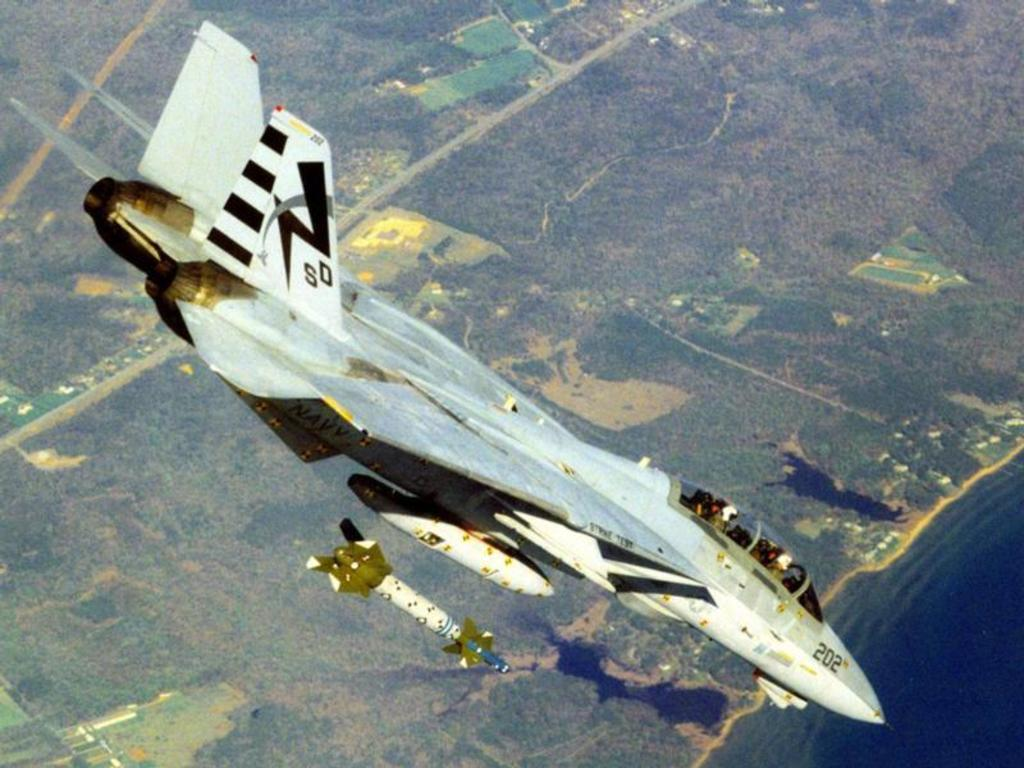Provide a one-sentence caption for the provided image. A bomb is dropped from a fighter jet with the letters SD and number 202 on it. 